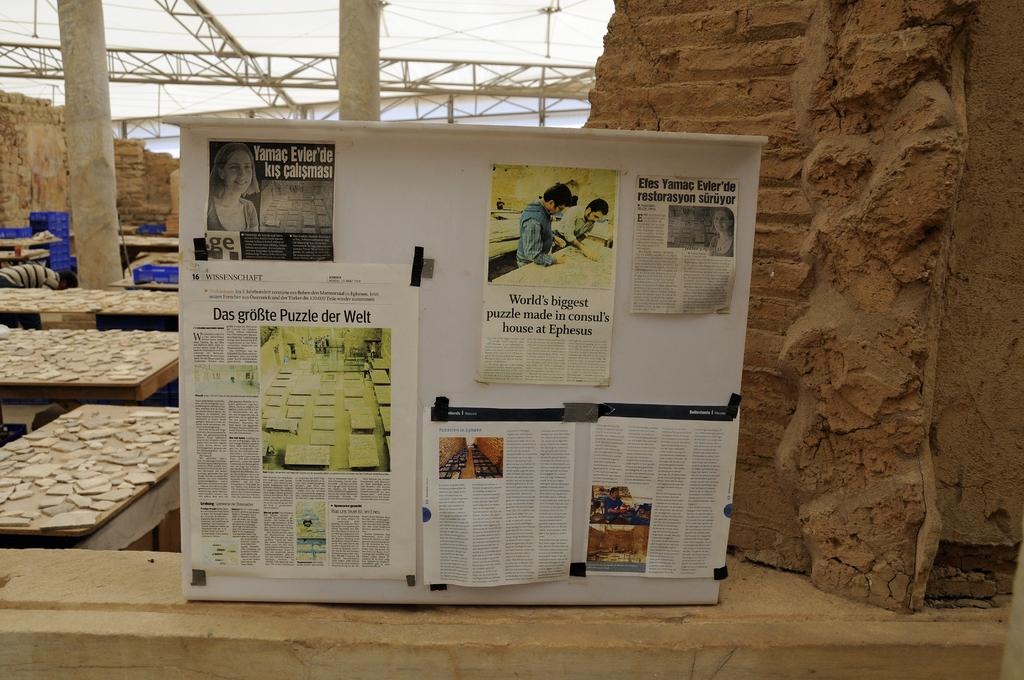<image>
Give a short and clear explanation of the subsequent image. A billboard at an archaeological site says World's biggest puzzle made in consul's house at Ephesus. 